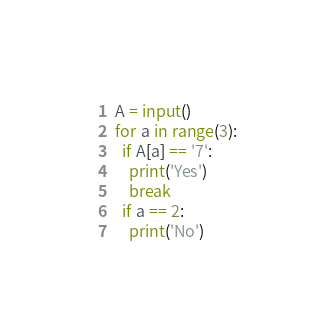Convert code to text. <code><loc_0><loc_0><loc_500><loc_500><_Python_>A = input()
for a in range(3):
  if A[a] == '7':
    print('Yes')
    break
  if a == 2:
    print('No')</code> 